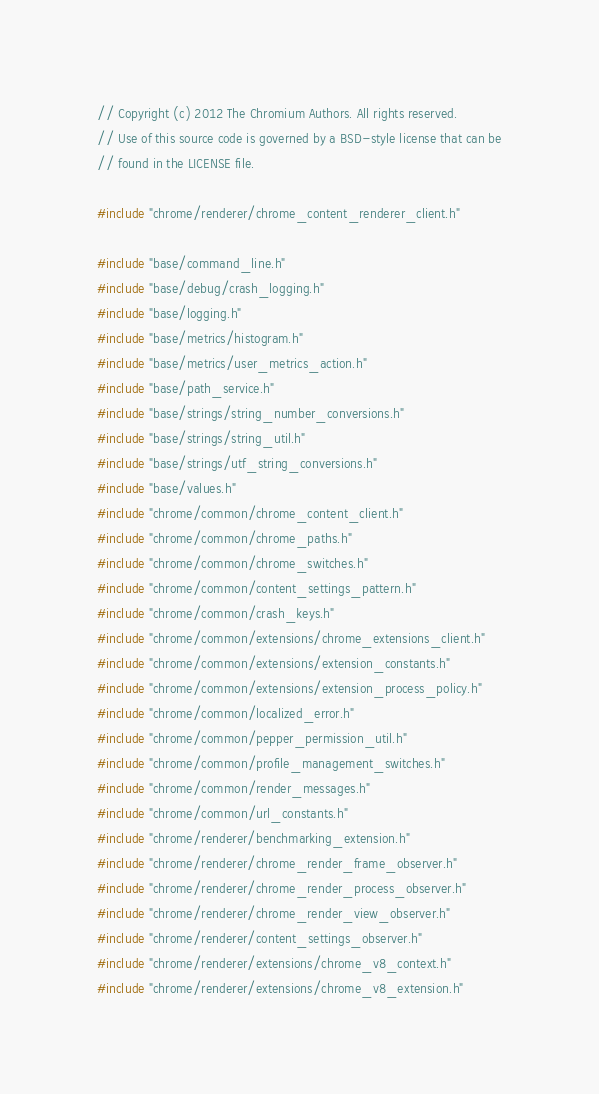<code> <loc_0><loc_0><loc_500><loc_500><_C++_>// Copyright (c) 2012 The Chromium Authors. All rights reserved.
// Use of this source code is governed by a BSD-style license that can be
// found in the LICENSE file.

#include "chrome/renderer/chrome_content_renderer_client.h"

#include "base/command_line.h"
#include "base/debug/crash_logging.h"
#include "base/logging.h"
#include "base/metrics/histogram.h"
#include "base/metrics/user_metrics_action.h"
#include "base/path_service.h"
#include "base/strings/string_number_conversions.h"
#include "base/strings/string_util.h"
#include "base/strings/utf_string_conversions.h"
#include "base/values.h"
#include "chrome/common/chrome_content_client.h"
#include "chrome/common/chrome_paths.h"
#include "chrome/common/chrome_switches.h"
#include "chrome/common/content_settings_pattern.h"
#include "chrome/common/crash_keys.h"
#include "chrome/common/extensions/chrome_extensions_client.h"
#include "chrome/common/extensions/extension_constants.h"
#include "chrome/common/extensions/extension_process_policy.h"
#include "chrome/common/localized_error.h"
#include "chrome/common/pepper_permission_util.h"
#include "chrome/common/profile_management_switches.h"
#include "chrome/common/render_messages.h"
#include "chrome/common/url_constants.h"
#include "chrome/renderer/benchmarking_extension.h"
#include "chrome/renderer/chrome_render_frame_observer.h"
#include "chrome/renderer/chrome_render_process_observer.h"
#include "chrome/renderer/chrome_render_view_observer.h"
#include "chrome/renderer/content_settings_observer.h"
#include "chrome/renderer/extensions/chrome_v8_context.h"
#include "chrome/renderer/extensions/chrome_v8_extension.h"</code> 